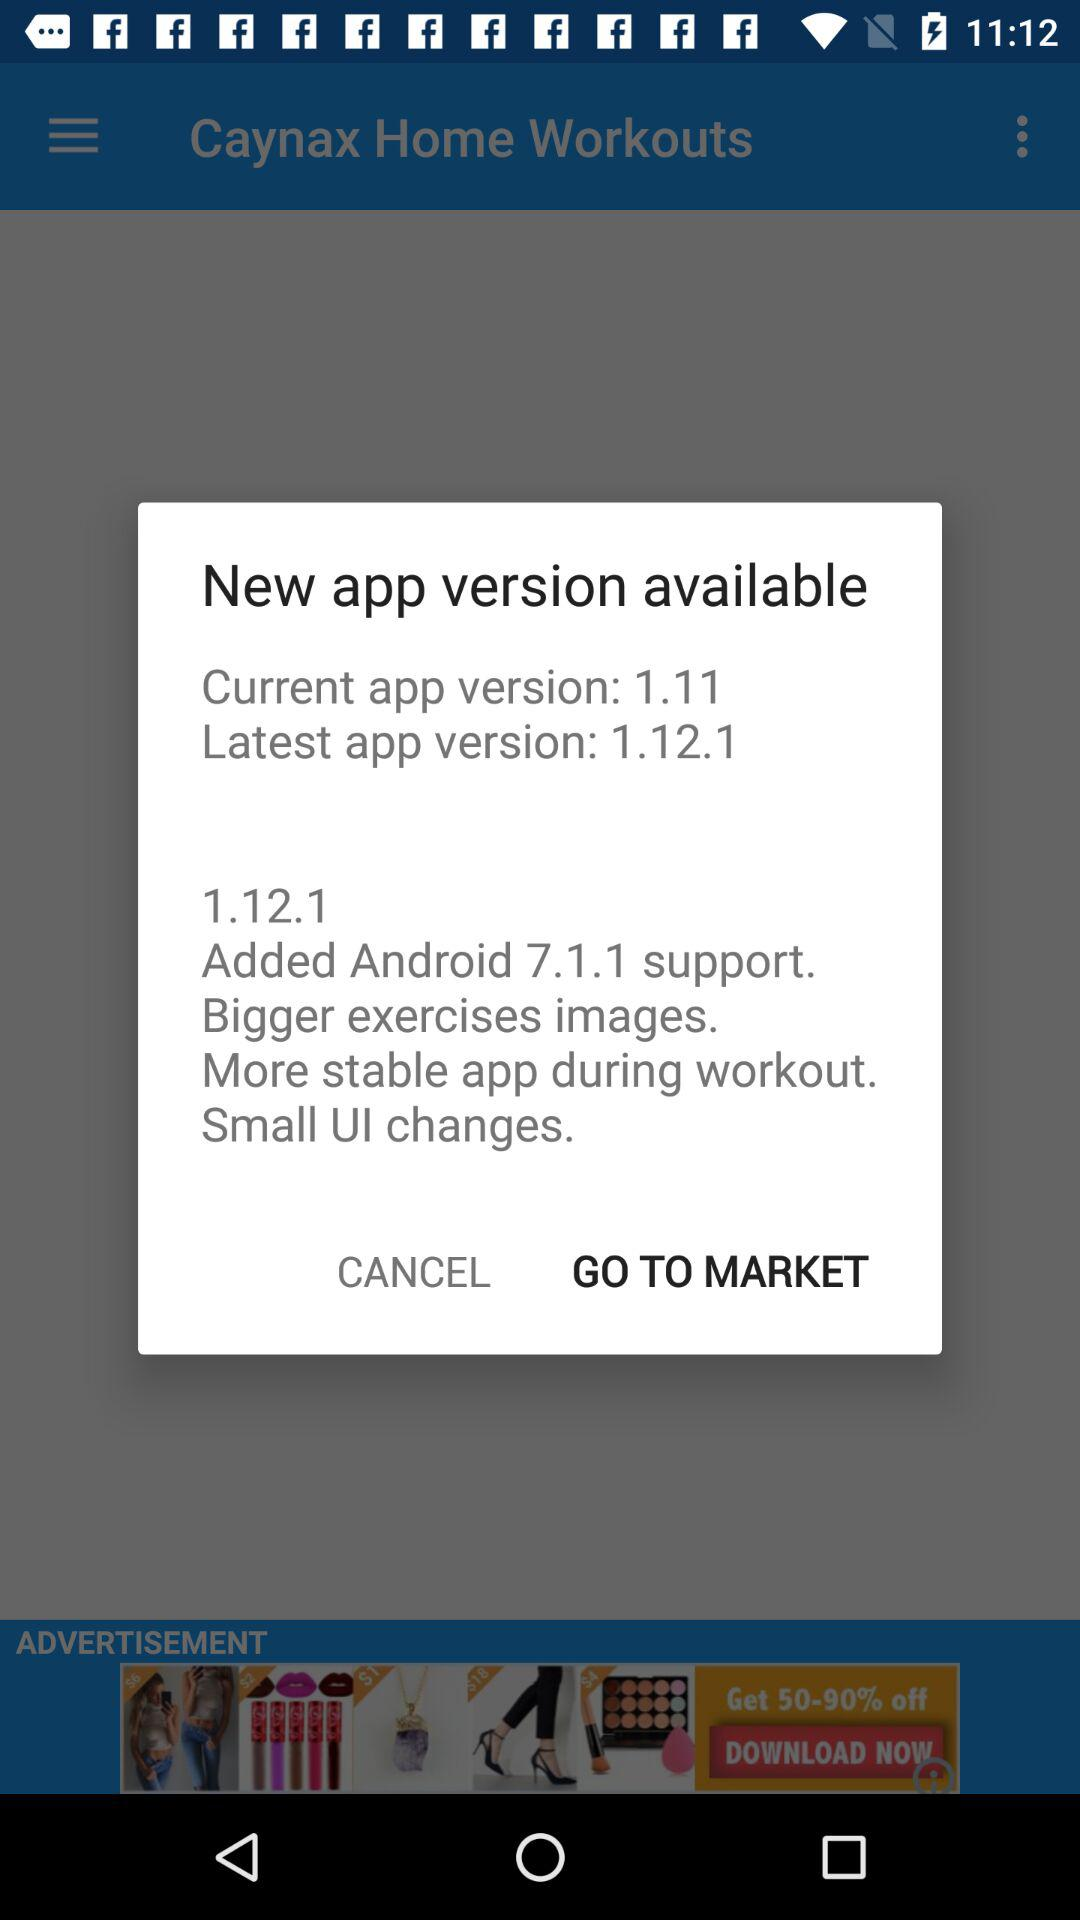What is the latest app version? The latest app version is 1.12.1. 